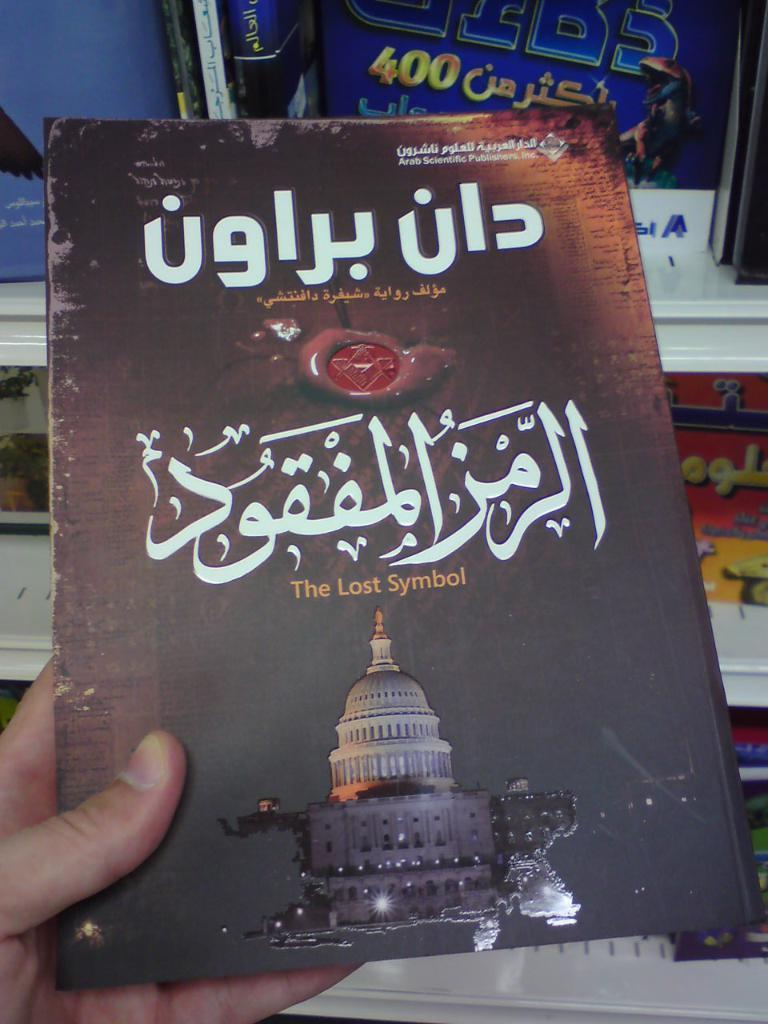<image>
Share a concise interpretation of the image provided. a copy of the book "the lost symbol' written in a middle eastern language. 